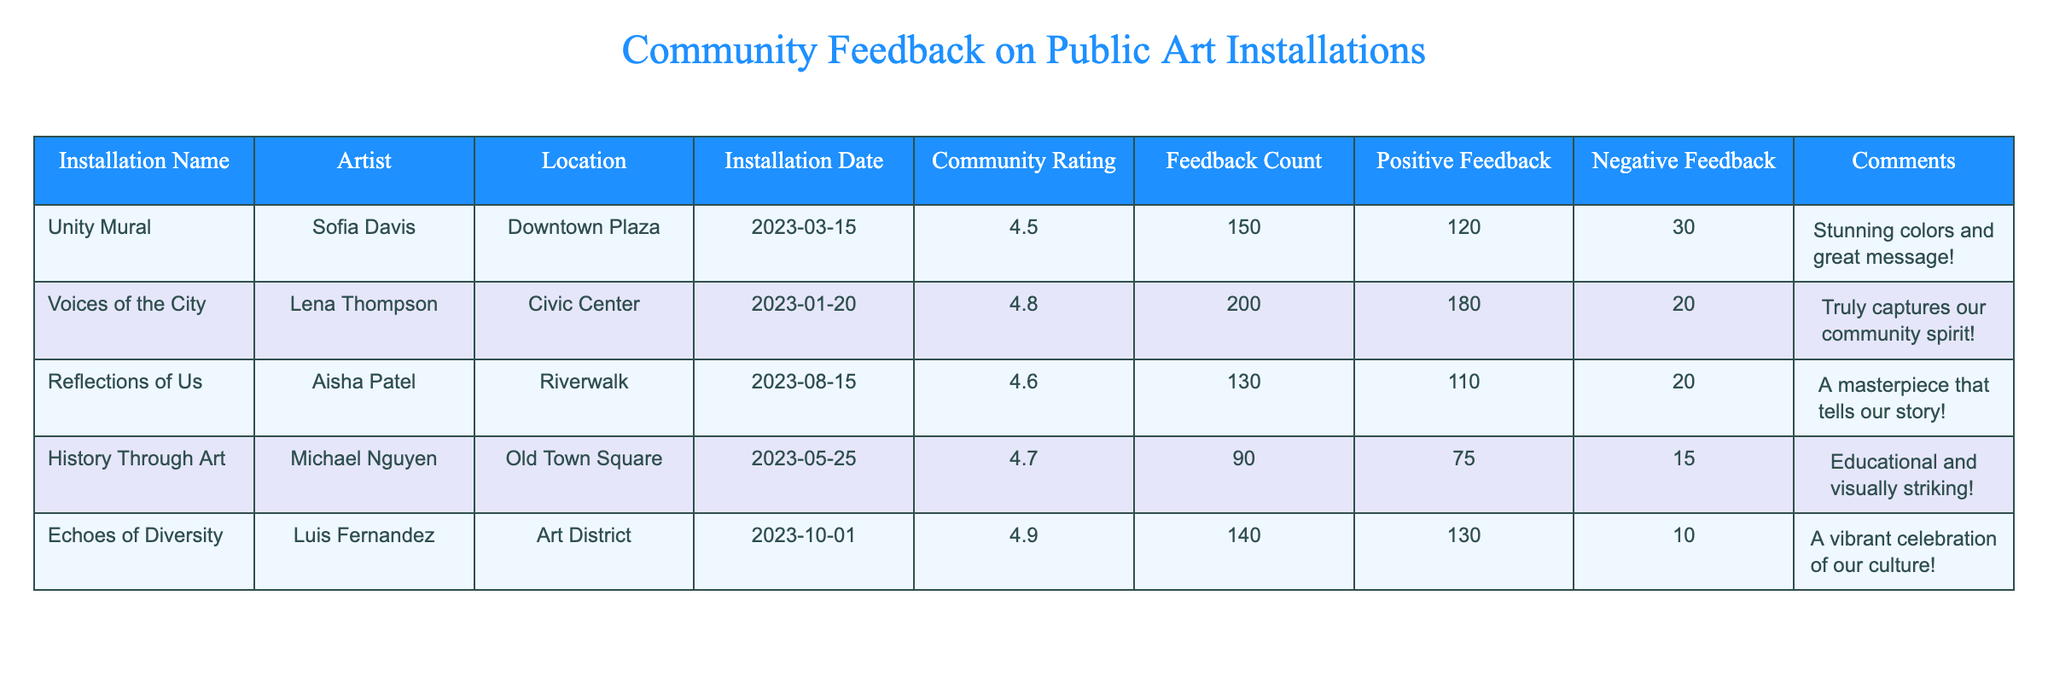What is the highest community rating among the installations? The highest community rating can be found by looking at the 'Community Rating' column, the top value there is 4.9 from the installation "Echoes of Diversity".
Answer: 4.9 Which installation received the most feedback? By examining the 'Feedback Count' column, "Voices of the City" has the highest count at 200.
Answer: 200 How many positive feedbacks did "History Through Art" receive? The positive feedback count can be directly found in the 'Positive Feedback' column for "History Through Art", which shows 75.
Answer: 75 What is the average community rating of all installations? To find the average, we sum the ratings (4.5 + 4.8 + 4.6 + 4.7 + 4.9 = 24.5) and divide by the number of installations (5), resulting in 24.5 / 5 = 4.9.
Answer: 4.9 Did "Unity Mural" receive more positive feedback than negative feedback? By comparing the 'Positive Feedback' (120) to 'Negative Feedback' (30), since 120 is greater than 30, it did receive more positive feedback.
Answer: Yes What is the total number of positive feedbacks across all installations? Adding all positive feedback values (120 + 180 + 110 + 75 + 130 = 615) gives a total of 615 positive feedbacks.
Answer: 615 Which installation has the least amount of feedback and what was the rating? "History Through Art" has the least feedback count of 90, with a community rating of 4.7, which can be found in their respective columns.
Answer: 90, 4.7 How many installations received a rating above 4.6? By checking the 'Community Rating' column, three installations ("Voices of the City", "Echoes of Diversity", "Reflections of Us") have ratings above 4.6.
Answer: 3 What is the difference in positive feedback between "Echoes of Diversity" and "Voices of the City"? Calculating the difference involves subtracting positive feedback counts (130 for "Echoes of Diversity" and 180 for "Voices of the City"), which results in 180 - 130 = 50.
Answer: 50 What percentage of total feedback for "Reflections of Us" was positive? First, calculate the total feedback for "Reflections of Us" (130), then find the percentage of positive feedback (110): (110 / 130) * 100 = 84.6%.
Answer: 84.6% 